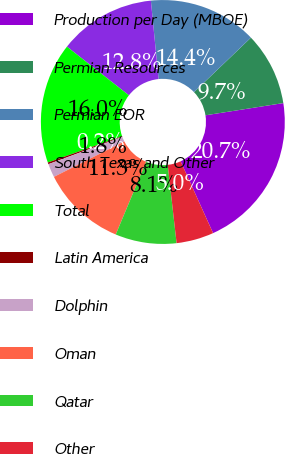Convert chart to OTSL. <chart><loc_0><loc_0><loc_500><loc_500><pie_chart><fcel>Production per Day (MBOE)<fcel>Permian Resources<fcel>Permian EOR<fcel>South Texas and Other<fcel>Total<fcel>Latin America<fcel>Dolphin<fcel>Oman<fcel>Qatar<fcel>Other<nl><fcel>20.72%<fcel>9.68%<fcel>14.41%<fcel>12.84%<fcel>15.99%<fcel>0.23%<fcel>1.81%<fcel>11.26%<fcel>8.11%<fcel>4.96%<nl></chart> 